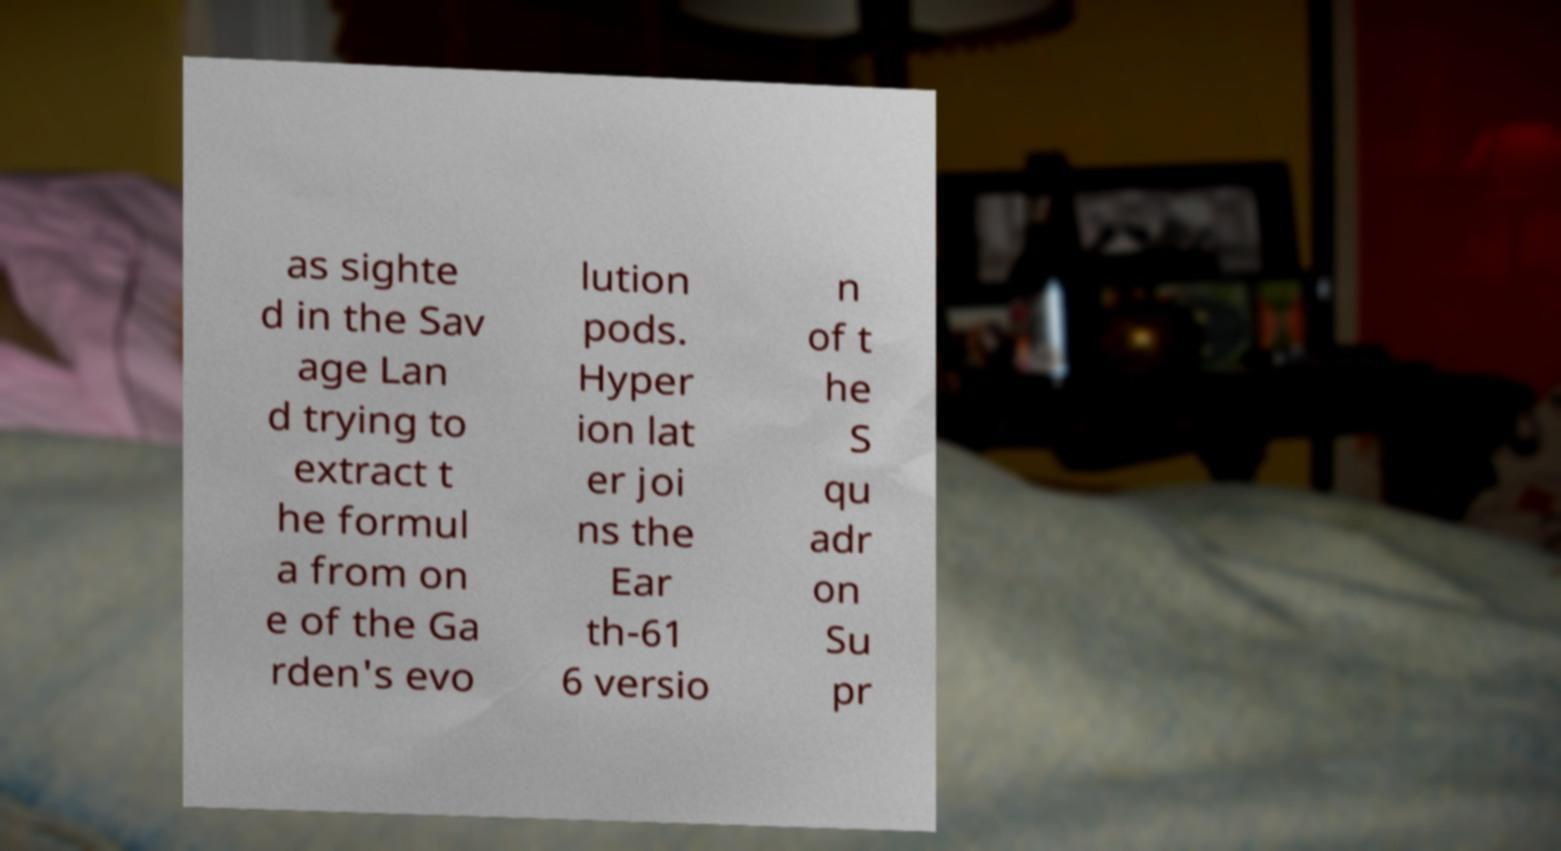For documentation purposes, I need the text within this image transcribed. Could you provide that? as sighte d in the Sav age Lan d trying to extract t he formul a from on e of the Ga rden's evo lution pods. Hyper ion lat er joi ns the Ear th-61 6 versio n of t he S qu adr on Su pr 